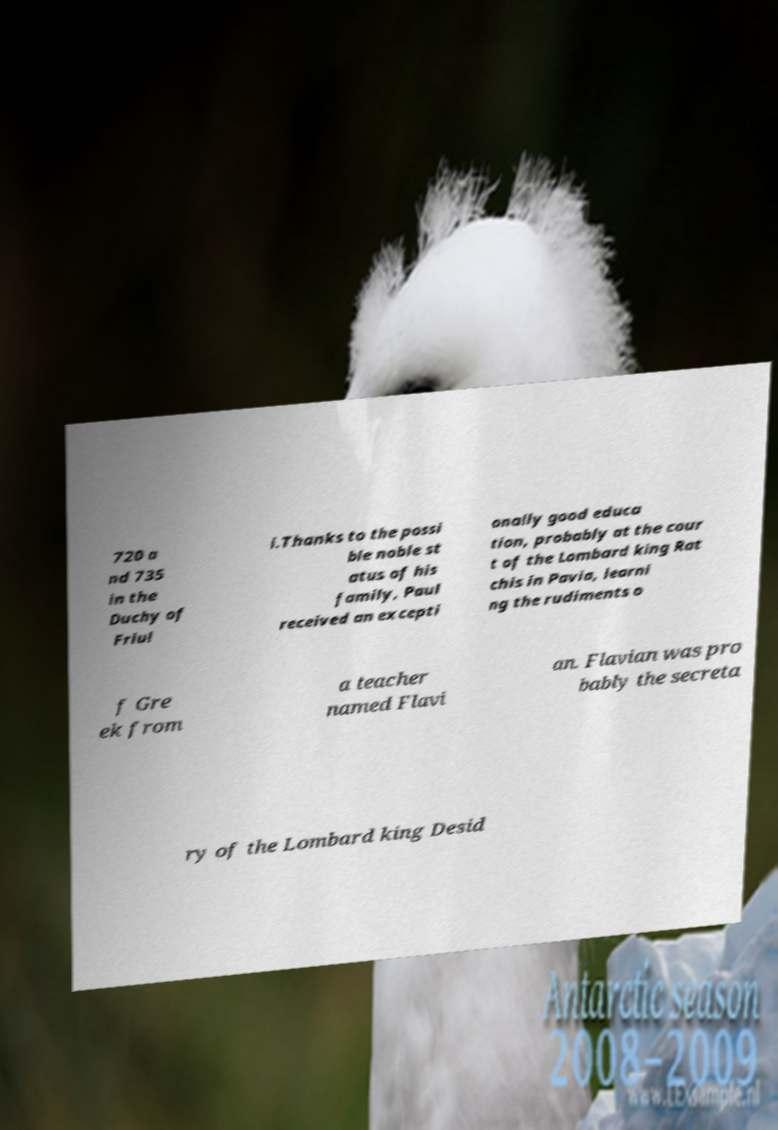For documentation purposes, I need the text within this image transcribed. Could you provide that? 720 a nd 735 in the Duchy of Friul i.Thanks to the possi ble noble st atus of his family, Paul received an excepti onally good educa tion, probably at the cour t of the Lombard king Rat chis in Pavia, learni ng the rudiments o f Gre ek from a teacher named Flavi an. Flavian was pro bably the secreta ry of the Lombard king Desid 